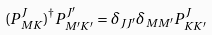<formula> <loc_0><loc_0><loc_500><loc_500>( P ^ { J } _ { M K } ) ^ { \dagger } P ^ { J ^ { \prime } } _ { M ^ { \prime } K ^ { \prime } } = \delta _ { J J ^ { \prime } } \delta _ { M M ^ { \prime } } P ^ { J } _ { K K ^ { \prime } }</formula> 